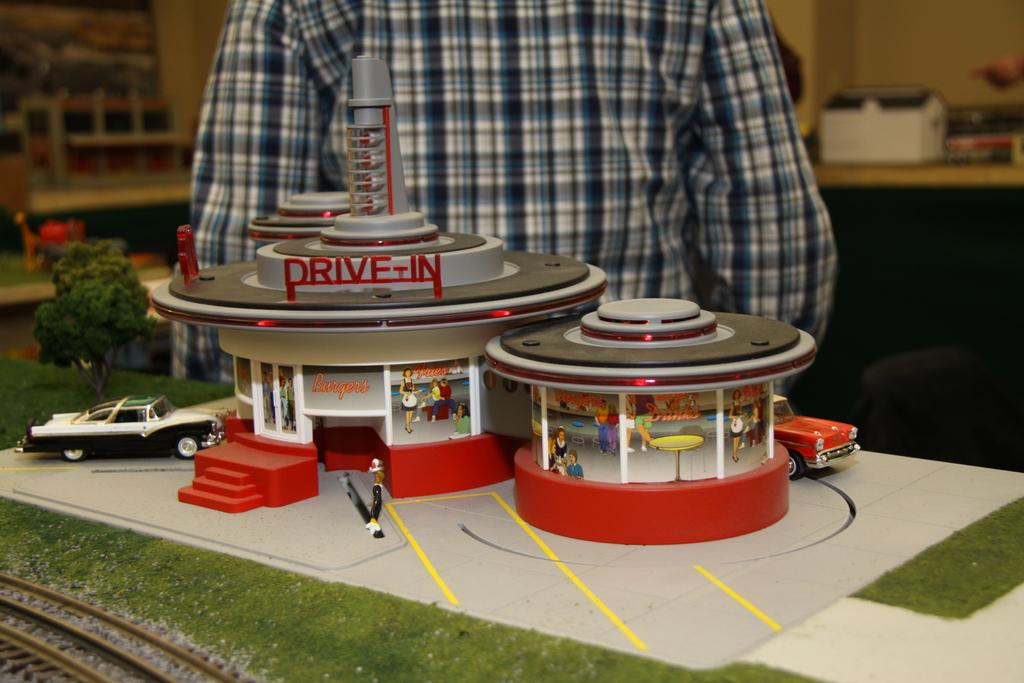<image>
Write a terse but informative summary of the picture. A small miniature diner in 50's style, named "Drive-In." 